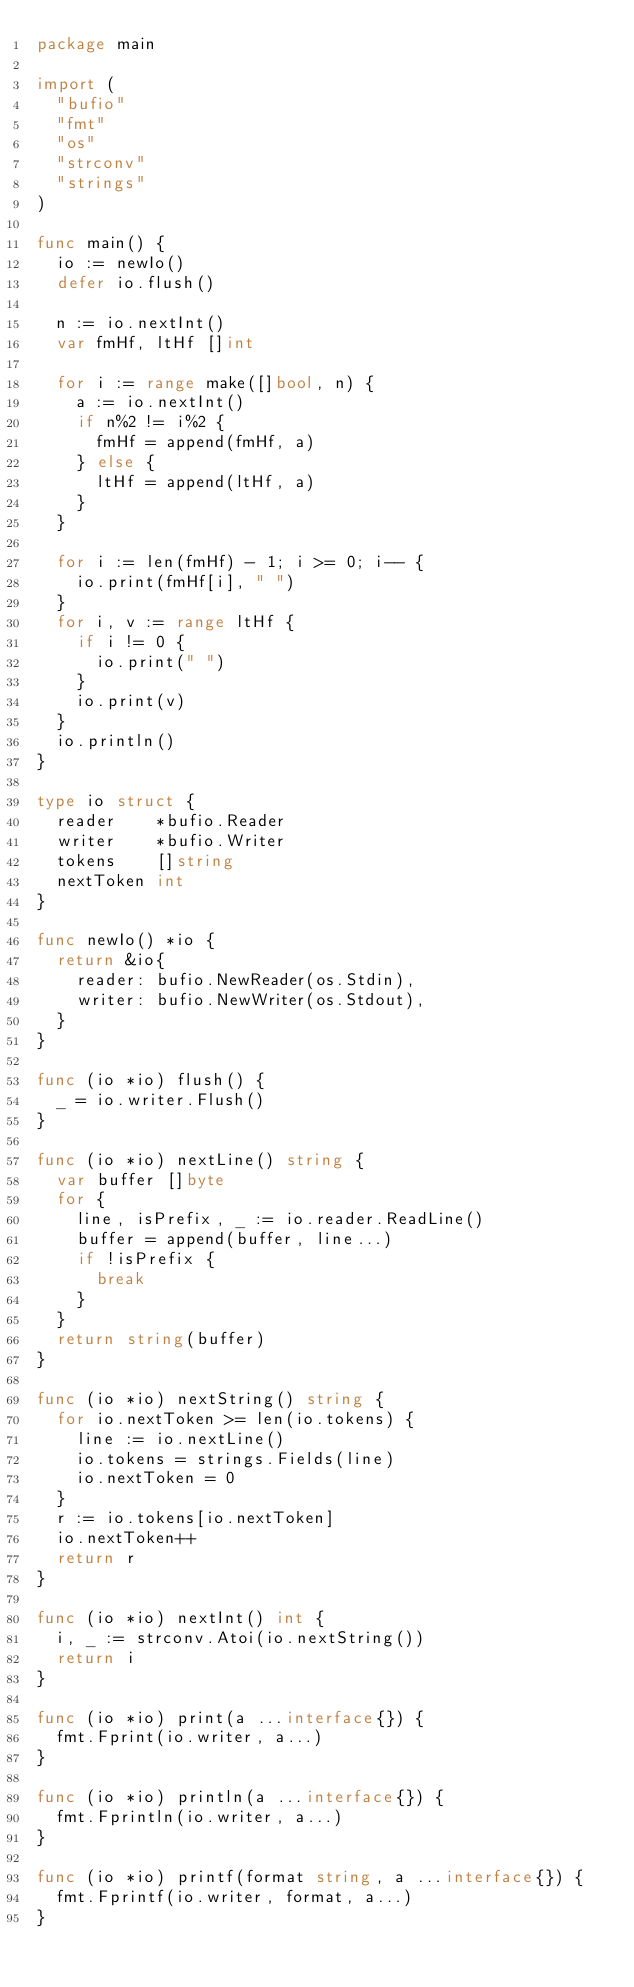Convert code to text. <code><loc_0><loc_0><loc_500><loc_500><_Go_>package main

import (
	"bufio"
	"fmt"
	"os"
	"strconv"
	"strings"
)

func main() {
	io := newIo()
	defer io.flush()

	n := io.nextInt()
	var fmHf, ltHf []int

	for i := range make([]bool, n) {
		a := io.nextInt()
		if n%2 != i%2 {
			fmHf = append(fmHf, a)
		} else {
			ltHf = append(ltHf, a)
		}
	}

	for i := len(fmHf) - 1; i >= 0; i-- {
		io.print(fmHf[i], " ")
	}
	for i, v := range ltHf {
		if i != 0 {
			io.print(" ")
		}
		io.print(v)
	}
	io.println()
}

type io struct {
	reader    *bufio.Reader
	writer    *bufio.Writer
	tokens    []string
	nextToken int
}

func newIo() *io {
	return &io{
		reader: bufio.NewReader(os.Stdin),
		writer: bufio.NewWriter(os.Stdout),
	}
}

func (io *io) flush() {
	_ = io.writer.Flush()
}

func (io *io) nextLine() string {
	var buffer []byte
	for {
		line, isPrefix, _ := io.reader.ReadLine()
		buffer = append(buffer, line...)
		if !isPrefix {
			break
		}
	}
	return string(buffer)
}

func (io *io) nextString() string {
	for io.nextToken >= len(io.tokens) {
		line := io.nextLine()
		io.tokens = strings.Fields(line)
		io.nextToken = 0
	}
	r := io.tokens[io.nextToken]
	io.nextToken++
	return r
}

func (io *io) nextInt() int {
	i, _ := strconv.Atoi(io.nextString())
	return i
}

func (io *io) print(a ...interface{}) {
	fmt.Fprint(io.writer, a...)
}

func (io *io) println(a ...interface{}) {
	fmt.Fprintln(io.writer, a...)
}

func (io *io) printf(format string, a ...interface{}) {
	fmt.Fprintf(io.writer, format, a...)
}
</code> 